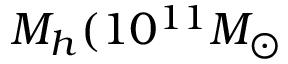<formula> <loc_0><loc_0><loc_500><loc_500>M _ { h } ( 1 0 ^ { 1 1 } M _ { \odot }</formula> 